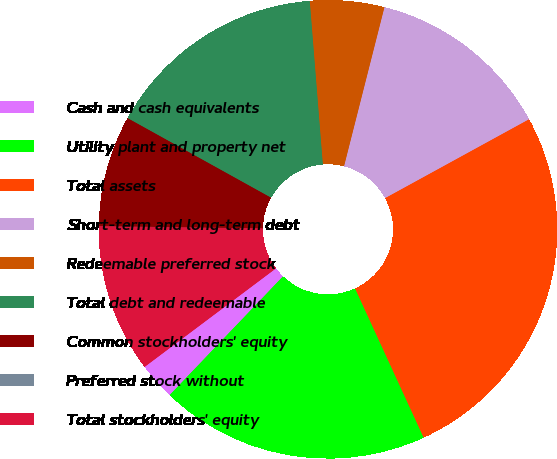Convert chart. <chart><loc_0><loc_0><loc_500><loc_500><pie_chart><fcel>Cash and cash equivalents<fcel>Utility plant and property net<fcel>Total assets<fcel>Short-term and long-term debt<fcel>Redeemable preferred stock<fcel>Total debt and redeemable<fcel>Common stockholders' equity<fcel>Preferred stock without<fcel>Total stockholders' equity<nl><fcel>2.62%<fcel>18.99%<fcel>26.12%<fcel>13.06%<fcel>5.23%<fcel>15.67%<fcel>7.84%<fcel>0.01%<fcel>10.45%<nl></chart> 